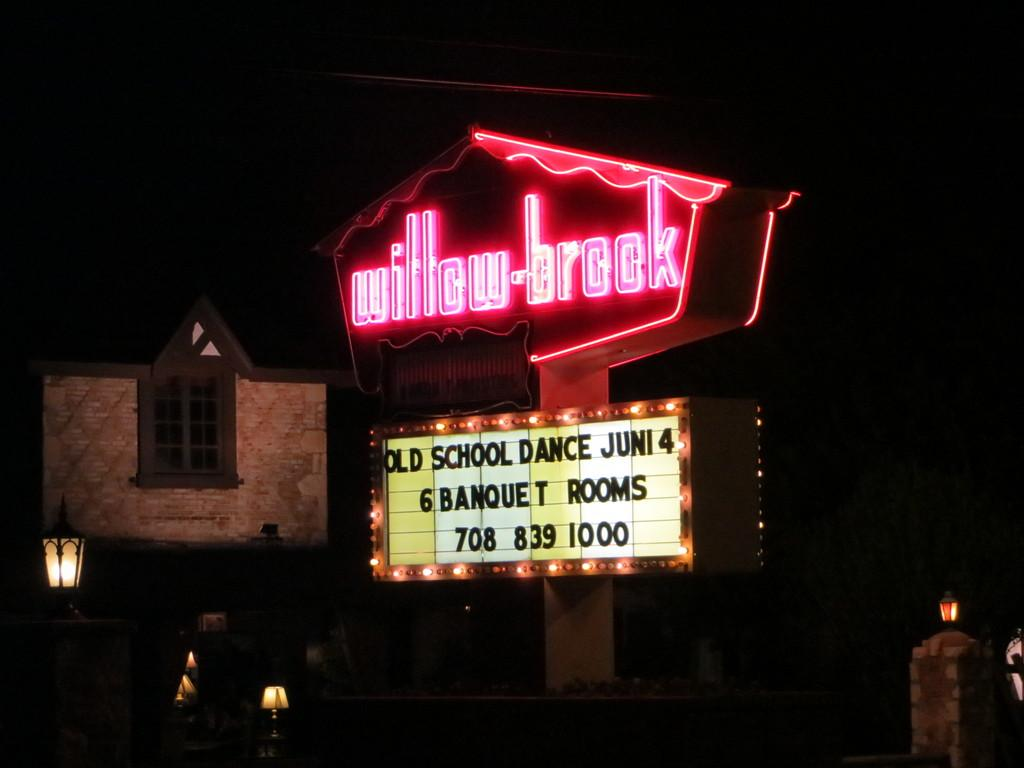What structures are present in the image? There are light poles and a hoarding board with lights in the image. What type of building can be seen in the background of the image? There is a house in the background of the image. How would you describe the lighting conditions in the image? The background of the image is dark. How many boys are holding a knife in the image? There are no boys or knives present in the image. 